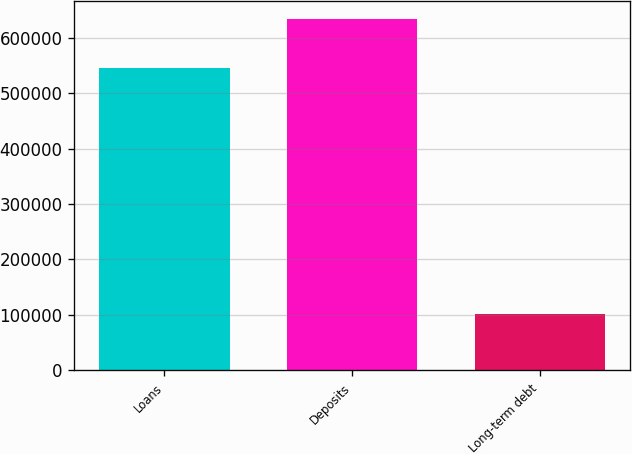Convert chart to OTSL. <chart><loc_0><loc_0><loc_500><loc_500><bar_chart><fcel>Loans<fcel>Deposits<fcel>Long-term debt<nl><fcel>545238<fcel>634670<fcel>100848<nl></chart> 